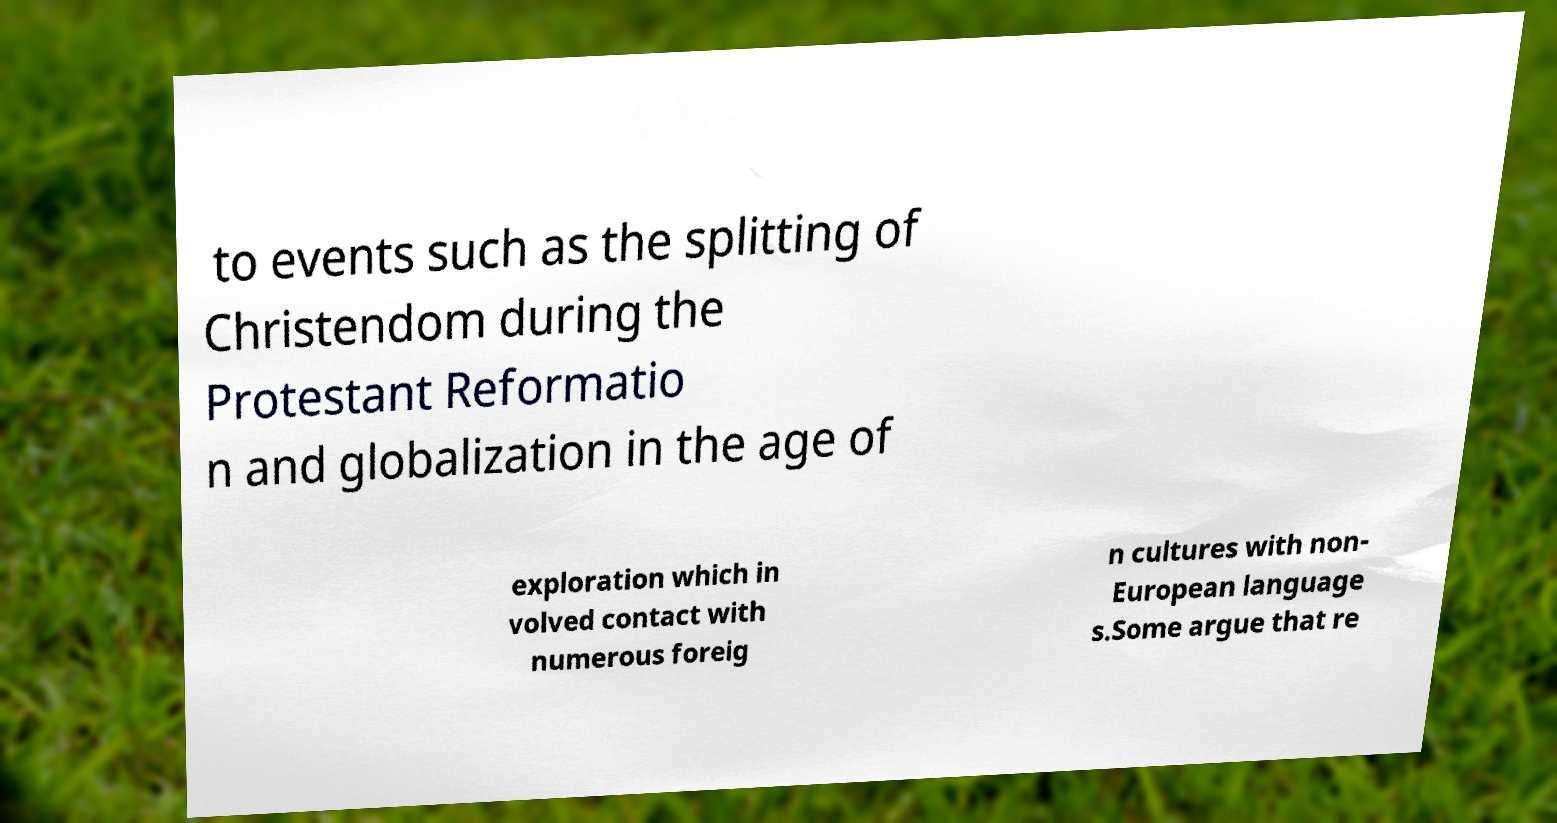What messages or text are displayed in this image? I need them in a readable, typed format. to events such as the splitting of Christendom during the Protestant Reformatio n and globalization in the age of exploration which in volved contact with numerous foreig n cultures with non- European language s.Some argue that re 